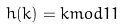<formula> <loc_0><loc_0><loc_500><loc_500>h ( k ) = k m o d 1 1</formula> 